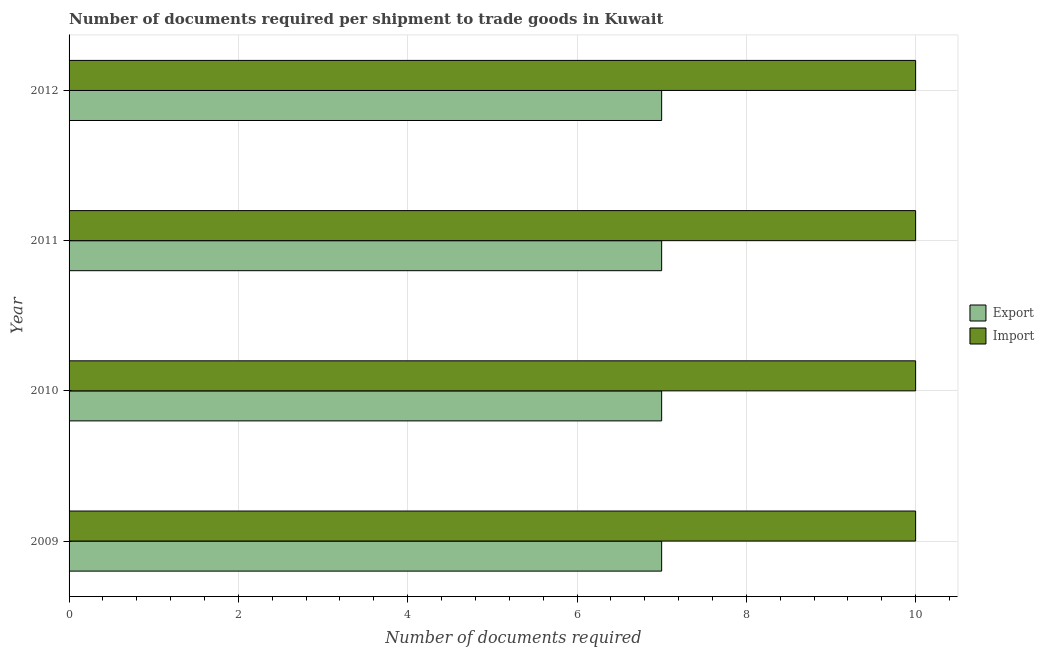How many different coloured bars are there?
Make the answer very short. 2. How many groups of bars are there?
Keep it short and to the point. 4. How many bars are there on the 2nd tick from the bottom?
Provide a short and direct response. 2. What is the label of the 3rd group of bars from the top?
Provide a succinct answer. 2010. In how many cases, is the number of bars for a given year not equal to the number of legend labels?
Provide a short and direct response. 0. What is the number of documents required to export goods in 2012?
Make the answer very short. 7. Across all years, what is the maximum number of documents required to export goods?
Provide a succinct answer. 7. Across all years, what is the minimum number of documents required to export goods?
Give a very brief answer. 7. In which year was the number of documents required to import goods minimum?
Offer a very short reply. 2009. What is the total number of documents required to export goods in the graph?
Give a very brief answer. 28. What is the difference between the number of documents required to export goods in 2009 and that in 2011?
Your answer should be very brief. 0. What is the difference between the number of documents required to export goods in 2010 and the number of documents required to import goods in 2012?
Your answer should be very brief. -3. What is the average number of documents required to export goods per year?
Ensure brevity in your answer.  7. In the year 2010, what is the difference between the number of documents required to import goods and number of documents required to export goods?
Make the answer very short. 3. In how many years, is the number of documents required to import goods greater than 5.2 ?
Your answer should be very brief. 4. What is the ratio of the number of documents required to import goods in 2009 to that in 2012?
Provide a succinct answer. 1. Is the number of documents required to export goods in 2009 less than that in 2011?
Keep it short and to the point. No. What does the 1st bar from the top in 2009 represents?
Offer a very short reply. Import. What does the 1st bar from the bottom in 2009 represents?
Offer a very short reply. Export. How many bars are there?
Keep it short and to the point. 8. How many years are there in the graph?
Your answer should be compact. 4. Are the values on the major ticks of X-axis written in scientific E-notation?
Ensure brevity in your answer.  No. What is the title of the graph?
Your answer should be very brief. Number of documents required per shipment to trade goods in Kuwait. What is the label or title of the X-axis?
Keep it short and to the point. Number of documents required. What is the label or title of the Y-axis?
Your answer should be compact. Year. What is the Number of documents required in Import in 2009?
Give a very brief answer. 10. What is the Number of documents required in Export in 2010?
Offer a terse response. 7. What is the Number of documents required of Import in 2010?
Your response must be concise. 10. What is the Number of documents required in Import in 2012?
Your response must be concise. 10. Across all years, what is the maximum Number of documents required in Export?
Make the answer very short. 7. Across all years, what is the minimum Number of documents required in Import?
Offer a terse response. 10. What is the total Number of documents required of Export in the graph?
Provide a succinct answer. 28. What is the difference between the Number of documents required in Export in 2009 and that in 2010?
Provide a short and direct response. 0. What is the difference between the Number of documents required of Import in 2009 and that in 2010?
Offer a very short reply. 0. What is the difference between the Number of documents required in Import in 2009 and that in 2011?
Your response must be concise. 0. What is the difference between the Number of documents required in Export in 2009 and that in 2012?
Offer a very short reply. 0. What is the difference between the Number of documents required of Export in 2010 and that in 2012?
Provide a short and direct response. 0. What is the difference between the Number of documents required in Export in 2011 and that in 2012?
Ensure brevity in your answer.  0. What is the difference between the Number of documents required in Import in 2011 and that in 2012?
Your answer should be very brief. 0. What is the difference between the Number of documents required in Export in 2009 and the Number of documents required in Import in 2010?
Offer a terse response. -3. What is the difference between the Number of documents required of Export in 2009 and the Number of documents required of Import in 2011?
Offer a terse response. -3. What is the difference between the Number of documents required of Export in 2010 and the Number of documents required of Import in 2011?
Your response must be concise. -3. What is the difference between the Number of documents required in Export in 2010 and the Number of documents required in Import in 2012?
Provide a short and direct response. -3. What is the average Number of documents required in Export per year?
Provide a succinct answer. 7. What is the average Number of documents required in Import per year?
Keep it short and to the point. 10. In the year 2009, what is the difference between the Number of documents required in Export and Number of documents required in Import?
Offer a terse response. -3. In the year 2010, what is the difference between the Number of documents required in Export and Number of documents required in Import?
Give a very brief answer. -3. In the year 2012, what is the difference between the Number of documents required in Export and Number of documents required in Import?
Offer a very short reply. -3. What is the ratio of the Number of documents required of Import in 2009 to that in 2010?
Provide a succinct answer. 1. What is the ratio of the Number of documents required of Export in 2009 to that in 2011?
Keep it short and to the point. 1. What is the ratio of the Number of documents required in Export in 2009 to that in 2012?
Give a very brief answer. 1. What is the ratio of the Number of documents required of Import in 2009 to that in 2012?
Offer a terse response. 1. What is the ratio of the Number of documents required of Export in 2010 to that in 2011?
Provide a short and direct response. 1. What is the ratio of the Number of documents required in Import in 2010 to that in 2011?
Offer a terse response. 1. What is the ratio of the Number of documents required of Import in 2010 to that in 2012?
Ensure brevity in your answer.  1. What is the difference between the highest and the second highest Number of documents required in Import?
Your response must be concise. 0. What is the difference between the highest and the lowest Number of documents required in Export?
Your response must be concise. 0. 